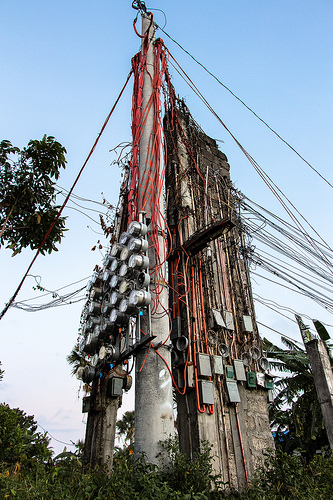<image>
Is there a power line next to the tree? Yes. The power line is positioned adjacent to the tree, located nearby in the same general area. Where is the tree in relation to the pole? Is it in front of the pole? No. The tree is not in front of the pole. The spatial positioning shows a different relationship between these objects. 